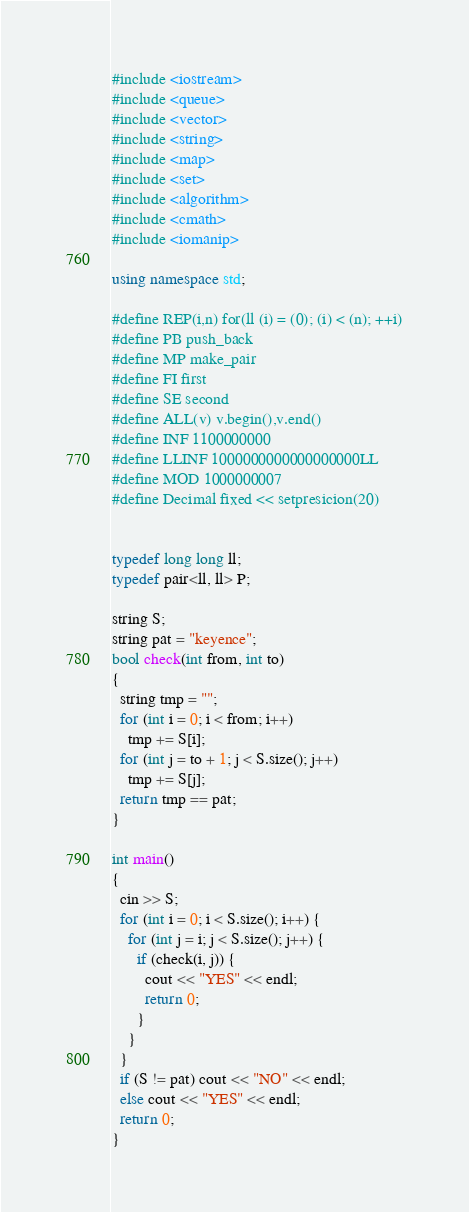<code> <loc_0><loc_0><loc_500><loc_500><_C++_>#include <iostream>
#include <queue>
#include <vector>
#include <string>
#include <map>
#include <set>
#include <algorithm>
#include <cmath>
#include <iomanip>

using namespace std;

#define REP(i,n) for(ll (i) = (0); (i) < (n); ++i)
#define PB push_back
#define MP make_pair
#define FI first
#define SE second
#define ALL(v) v.begin(),v.end()
#define INF 1100000000
#define LLINF 1000000000000000000LL
#define MOD 1000000007
#define Decimal fixed << setpresicion(20)


typedef long long ll;
typedef pair<ll, ll> P;

string S;
string pat = "keyence";
bool check(int from, int to)
{
  string tmp = "";
  for (int i = 0; i < from; i++)
    tmp += S[i];
  for (int j = to + 1; j < S.size(); j++)
    tmp += S[j];
  return tmp == pat;
}

int main()
{
  cin >> S;
  for (int i = 0; i < S.size(); i++) {
    for (int j = i; j < S.size(); j++) {
      if (check(i, j)) {
        cout << "YES" << endl;
        return 0;
      }
    }
  }
  if (S != pat) cout << "NO" << endl;
  else cout << "YES" << endl;
  return 0;
}

</code> 